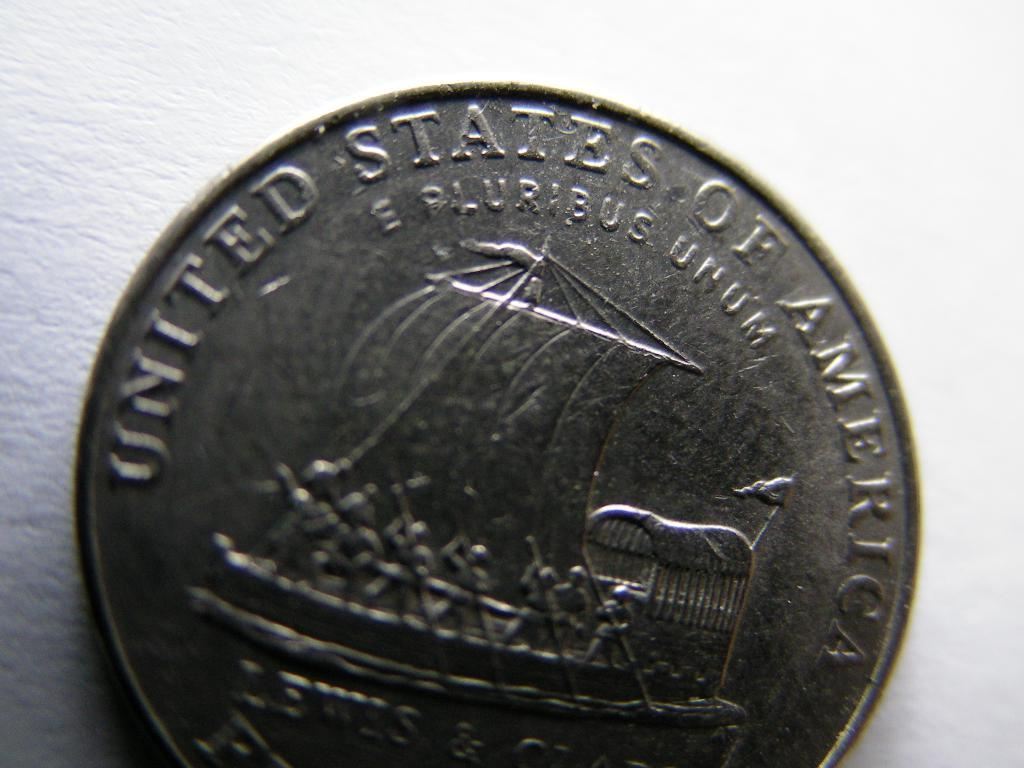<image>
Render a clear and concise summary of the photo. A United States five cent coin featuring explorers Lewis and Clark. 